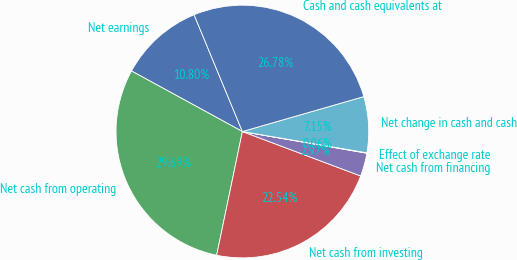Convert chart. <chart><loc_0><loc_0><loc_500><loc_500><pie_chart><fcel>Net earnings<fcel>Net cash from operating<fcel>Net cash from investing<fcel>Net cash from financing<fcel>Effect of exchange rate<fcel>Net change in cash and cash<fcel>Cash and cash equivalents at<nl><fcel>10.8%<fcel>29.69%<fcel>22.54%<fcel>2.97%<fcel>0.06%<fcel>7.15%<fcel>26.78%<nl></chart> 